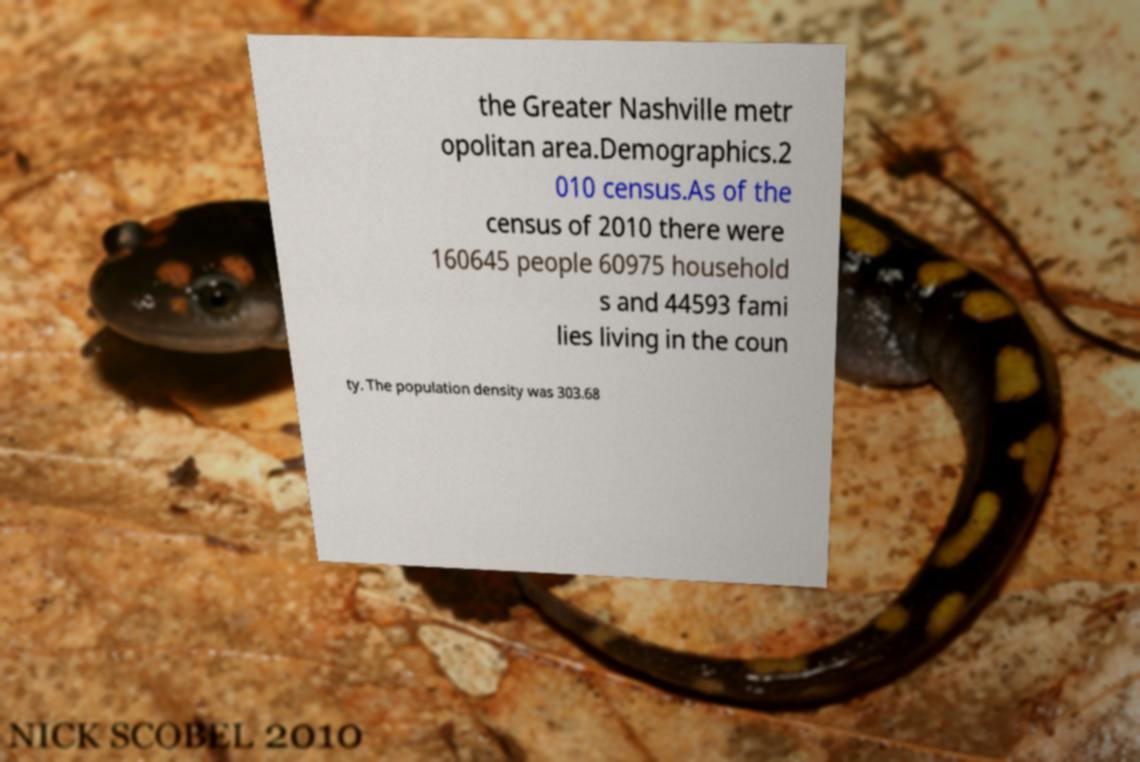There's text embedded in this image that I need extracted. Can you transcribe it verbatim? the Greater Nashville metr opolitan area.Demographics.2 010 census.As of the census of 2010 there were 160645 people 60975 household s and 44593 fami lies living in the coun ty. The population density was 303.68 